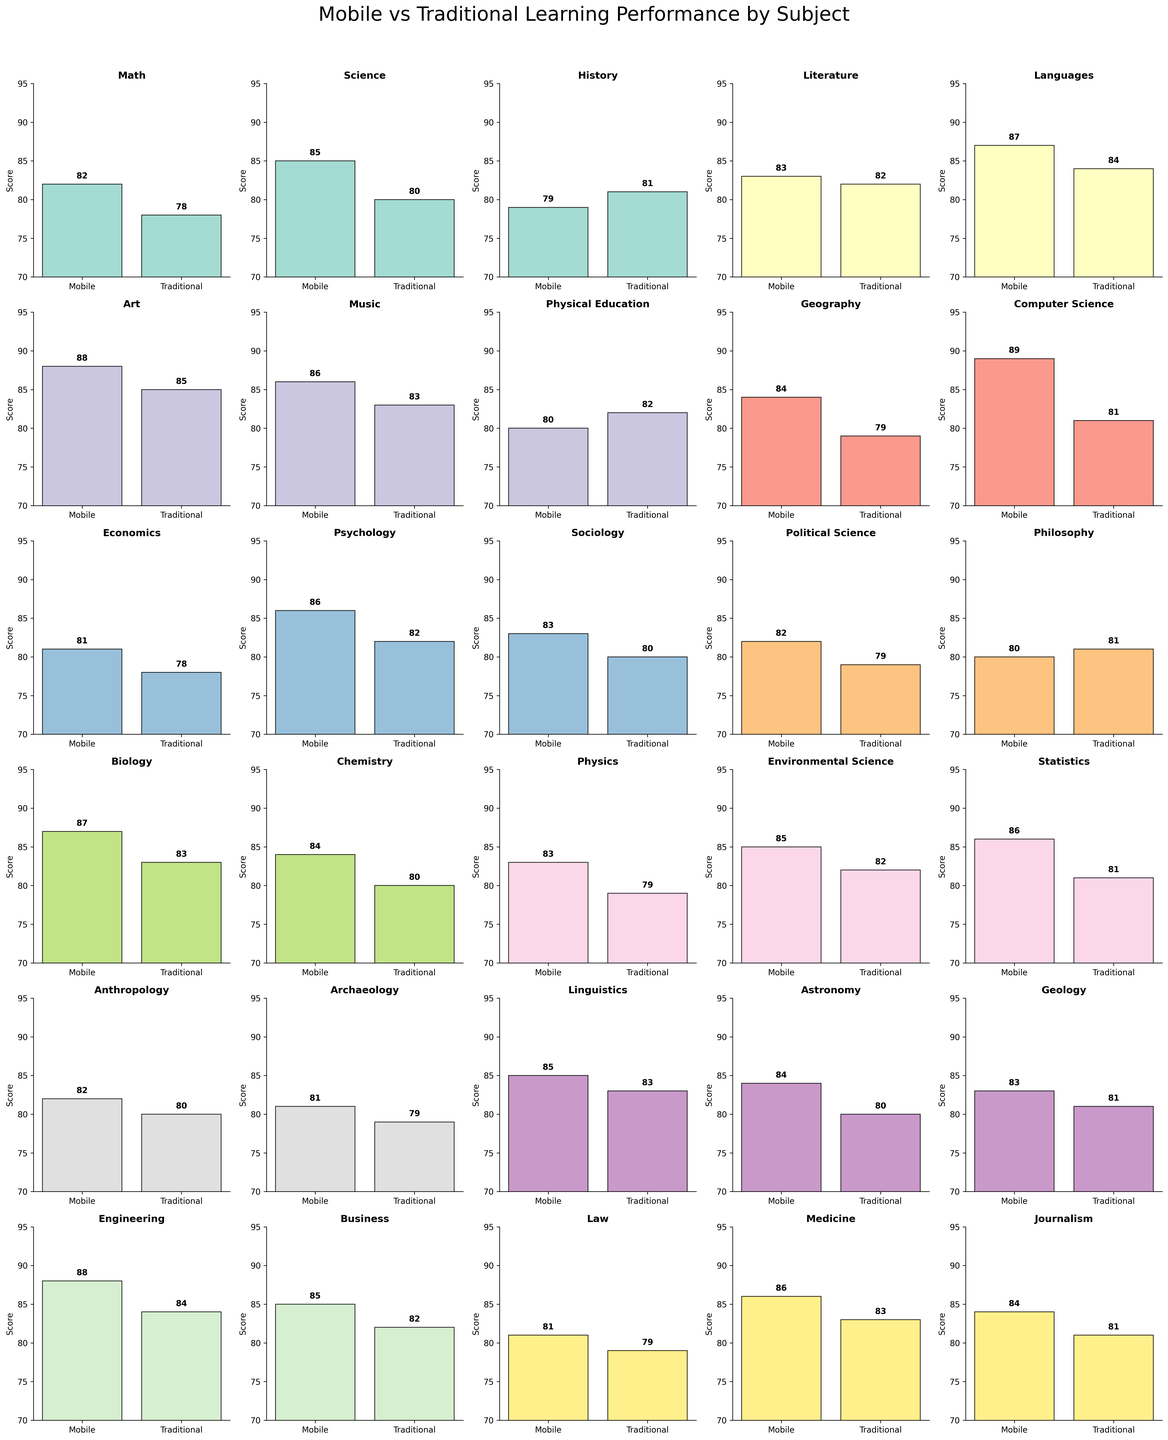What is the difference in scores between mobile-based and traditional learning for Math? Determine the scores for both mobile-based and traditional learning methods for Math. Subtract the traditional score (78) from the mobile score (82).
Answer: 4 Which subject shows the highest score in mobile-based learning? Look at the mobile scores for each subject and identify the highest value. The highest score in mobile-based learning is 89 for Computer Science.
Answer: Computer Science In how many subjects is the mobile learning score higher than the traditional learning score? Compare the mobile and traditional scores for each subject. Count the number of subjects where the mobile score is greater than the traditional score.
Answer: 23 What is the average score for traditional learning across all subjects? Sum up all the traditional scores and then divide by the total number of subjects. The total sum is (78 + 80 + 81 + 82 + 84 + 85 + 83 + 82 + 79 + 81 + 78 + 82 + 80 + 79 + 81 + 83 + 80 + 79 + 82 + 81 + 80 + 79 + 83 + 80 + 81 + 84 + 82 + 79 + 83 + 81) = 2437. Divide this by the number of subjects (30) to get the average.
Answer: 81.23 